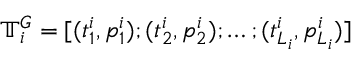Convert formula to latex. <formula><loc_0><loc_0><loc_500><loc_500>\mathbb { T } _ { i } ^ { G } = [ ( t _ { 1 } ^ { i } , p _ { 1 } ^ { i } ) ; ( t _ { 2 } ^ { i } , p _ { 2 } ^ { i } ) ; \dots ; ( t _ { L _ { i } } ^ { i } , p _ { L _ { i } } ^ { i } ) ]</formula> 